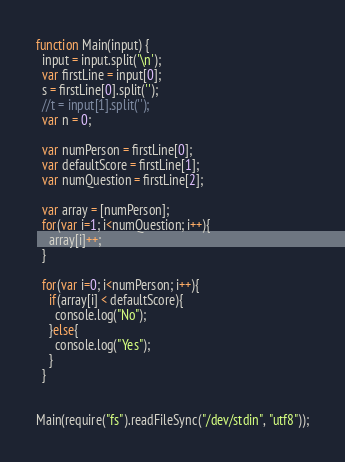Convert code to text. <code><loc_0><loc_0><loc_500><loc_500><_JavaScript_>function Main(input) {
  input = input.split('\n');
  var firstLine = input[0];
  s = firstLine[0].split('');
  //t = input[1].split('');
  var n = 0;
 
  var numPerson = firstLine[0];
  var defaultScore = firstLine[1];
  var numQuestion = firstLine[2];

  var array = [numPerson];
  for(var i=1; i<numQuestion; i++){
    array[i]++;
  }

  for(var i=0; i<numPerson; i++){
    if(array[i] < defaultScore){
      console.log("No");
    }else{
      console.log("Yes");
    }
  }

 
Main(require("fs").readFileSync("/dev/stdin", "utf8"));</code> 